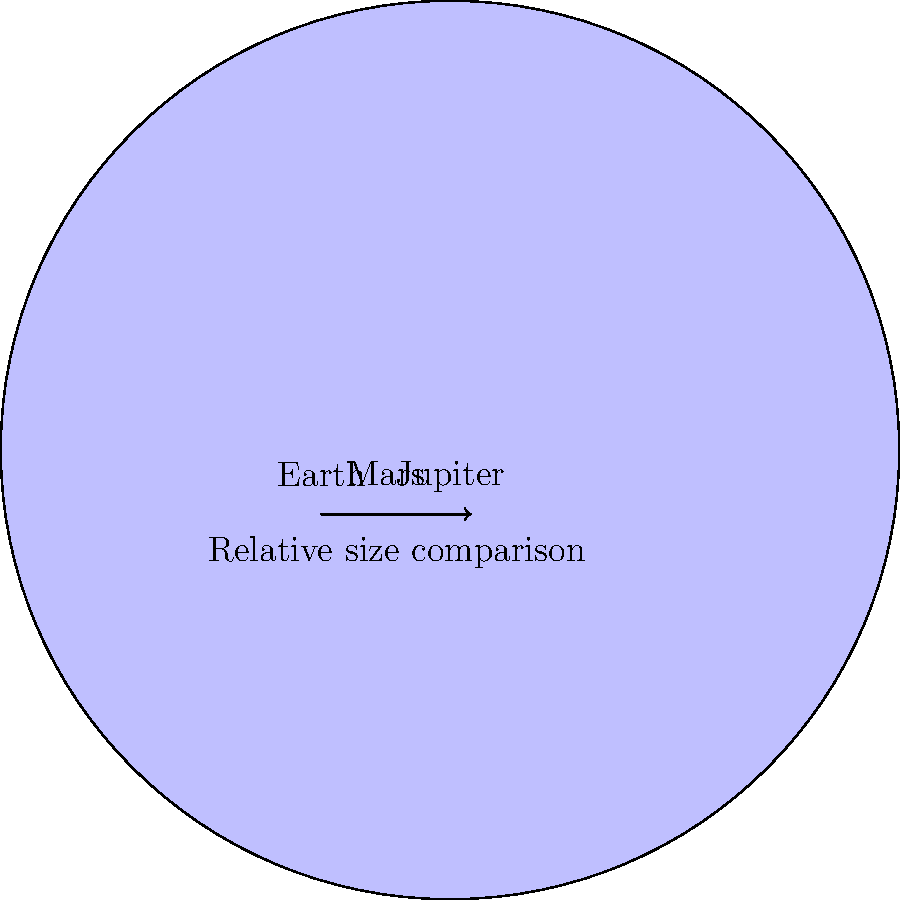In the contemporary art world, scale and proportion are often crucial elements in installation pieces. Similarly, in our solar system, the relative sizes of planets provide a fascinating perspective. Based on the scaled diagram above, which shows Earth, Mars, and Jupiter, approximately how many times larger is Jupiter's diameter compared to Earth's? To determine how many times larger Jupiter's diameter is compared to Earth's, we need to follow these steps:

1. Observe the scaled diagram, which accurately represents the relative sizes of Earth, Mars, and Jupiter.

2. The actual diameters of these planets are:
   Earth: 12,742 km
   Mars: 6,779 km
   Jupiter: 139,820 km

3. To calculate the ratio, we divide Jupiter's diameter by Earth's diameter:

   $\frac{\text{Jupiter's diameter}}{\text{Earth's diameter}} = \frac{139,820 \text{ km}}{12,742 \text{ km}} \approx 10.97$

4. Rounding to the nearest whole number, we get 11.

This means that Jupiter's diameter is approximately 11 times larger than Earth's diameter.

The diagram visually confirms this relationship, showing Jupiter as significantly larger than Earth, with Mars being the smallest of the three depicted planets.
Answer: 11 times 